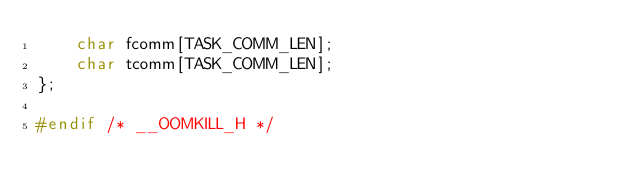<code> <loc_0><loc_0><loc_500><loc_500><_C_>	char fcomm[TASK_COMM_LEN];
	char tcomm[TASK_COMM_LEN];
};

#endif /* __OOMKILL_H */
</code> 